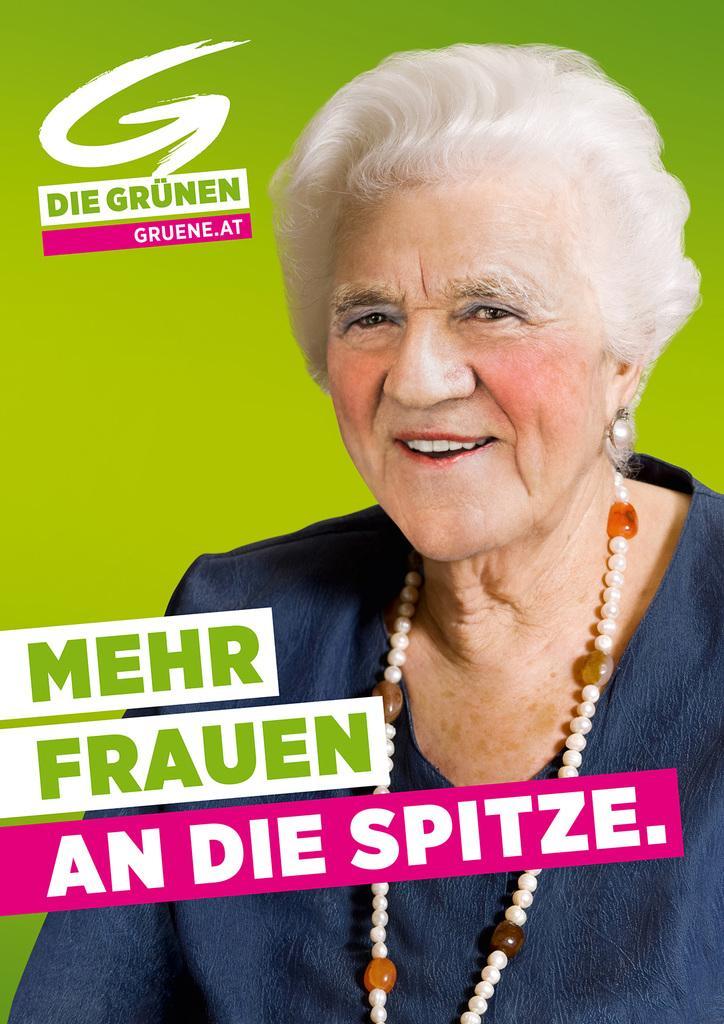In one or two sentences, can you explain what this image depicts? In this image we can see a woman smiling and some text. 